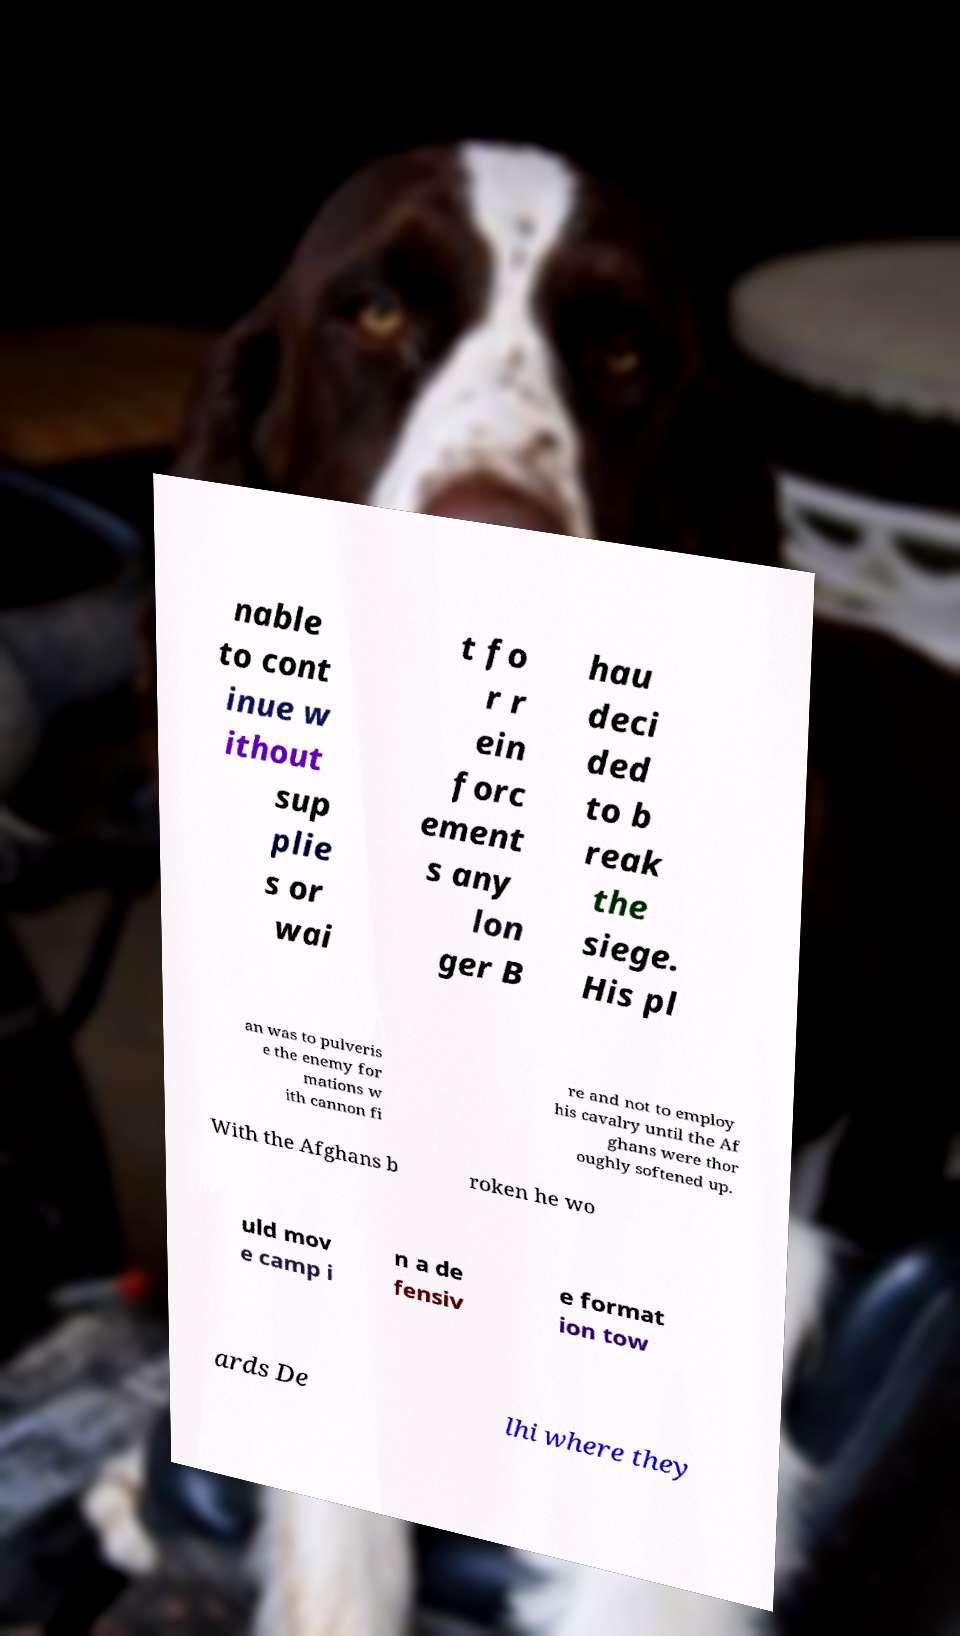Please read and relay the text visible in this image. What does it say? nable to cont inue w ithout sup plie s or wai t fo r r ein forc ement s any lon ger B hau deci ded to b reak the siege. His pl an was to pulveris e the enemy for mations w ith cannon fi re and not to employ his cavalry until the Af ghans were thor oughly softened up. With the Afghans b roken he wo uld mov e camp i n a de fensiv e format ion tow ards De lhi where they 